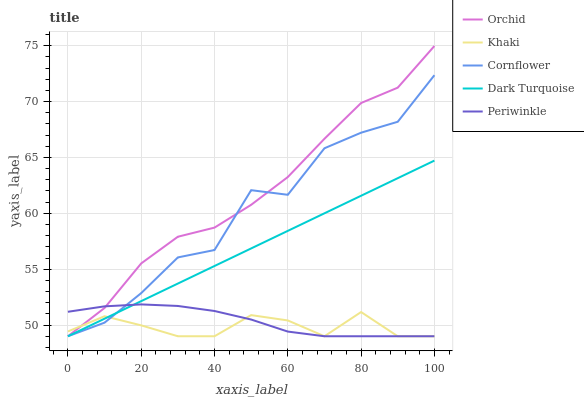Does Khaki have the minimum area under the curve?
Answer yes or no. Yes. Does Orchid have the maximum area under the curve?
Answer yes or no. Yes. Does Periwinkle have the minimum area under the curve?
Answer yes or no. No. Does Periwinkle have the maximum area under the curve?
Answer yes or no. No. Is Dark Turquoise the smoothest?
Answer yes or no. Yes. Is Cornflower the roughest?
Answer yes or no. Yes. Is Khaki the smoothest?
Answer yes or no. No. Is Khaki the roughest?
Answer yes or no. No. Does Cornflower have the lowest value?
Answer yes or no. Yes. Does Orchid have the highest value?
Answer yes or no. Yes. Does Periwinkle have the highest value?
Answer yes or no. No. Does Cornflower intersect Khaki?
Answer yes or no. Yes. Is Cornflower less than Khaki?
Answer yes or no. No. Is Cornflower greater than Khaki?
Answer yes or no. No. 